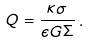<formula> <loc_0><loc_0><loc_500><loc_500>Q = \frac { \kappa \sigma } { \epsilon G \Sigma } \, .</formula> 